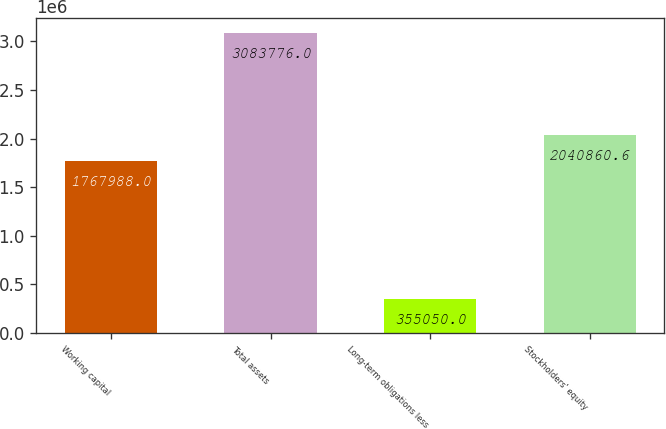Convert chart. <chart><loc_0><loc_0><loc_500><loc_500><bar_chart><fcel>Working capital<fcel>Total assets<fcel>Long-term obligations less<fcel>Stockholders' equity<nl><fcel>1.76799e+06<fcel>3.08378e+06<fcel>355050<fcel>2.04086e+06<nl></chart> 